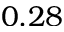Convert formula to latex. <formula><loc_0><loc_0><loc_500><loc_500>0 . 2 8</formula> 